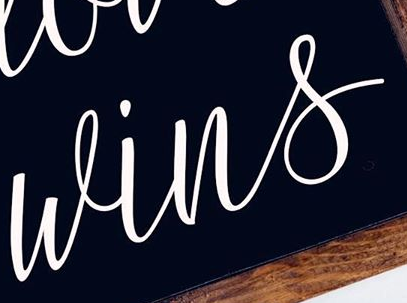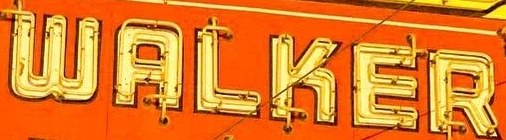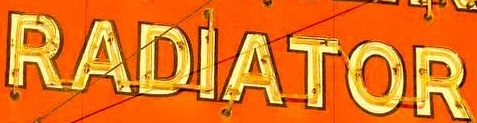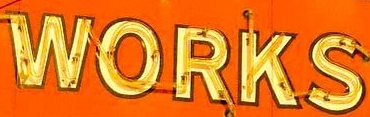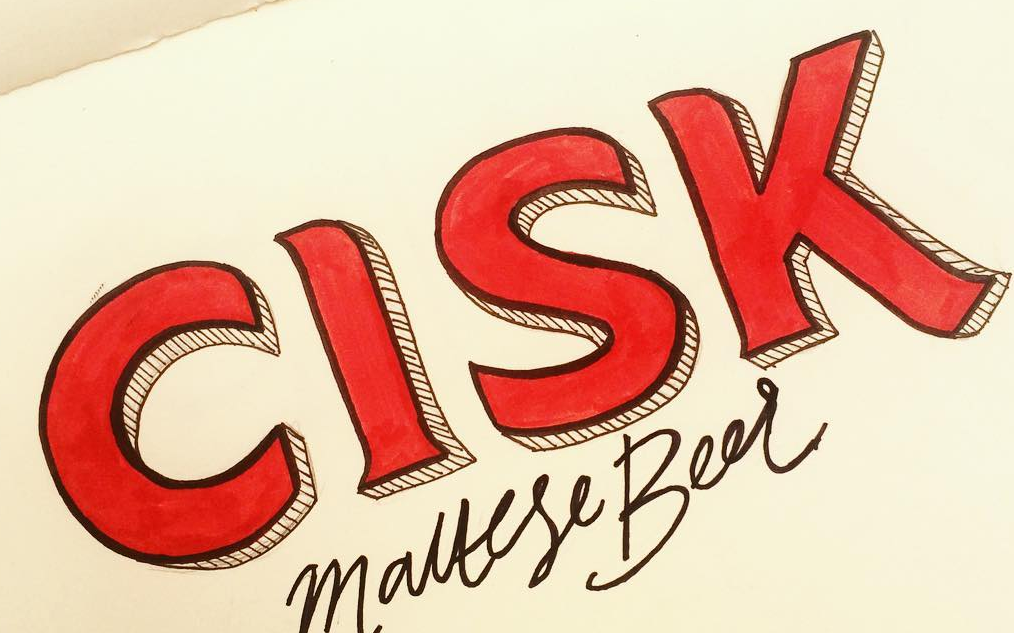What words are shown in these images in order, separated by a semicolon? wins; WALKER; RADIATOR; WORKS; CISK 